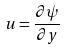Convert formula to latex. <formula><loc_0><loc_0><loc_500><loc_500>u = \frac { \partial \psi } { \partial y }</formula> 